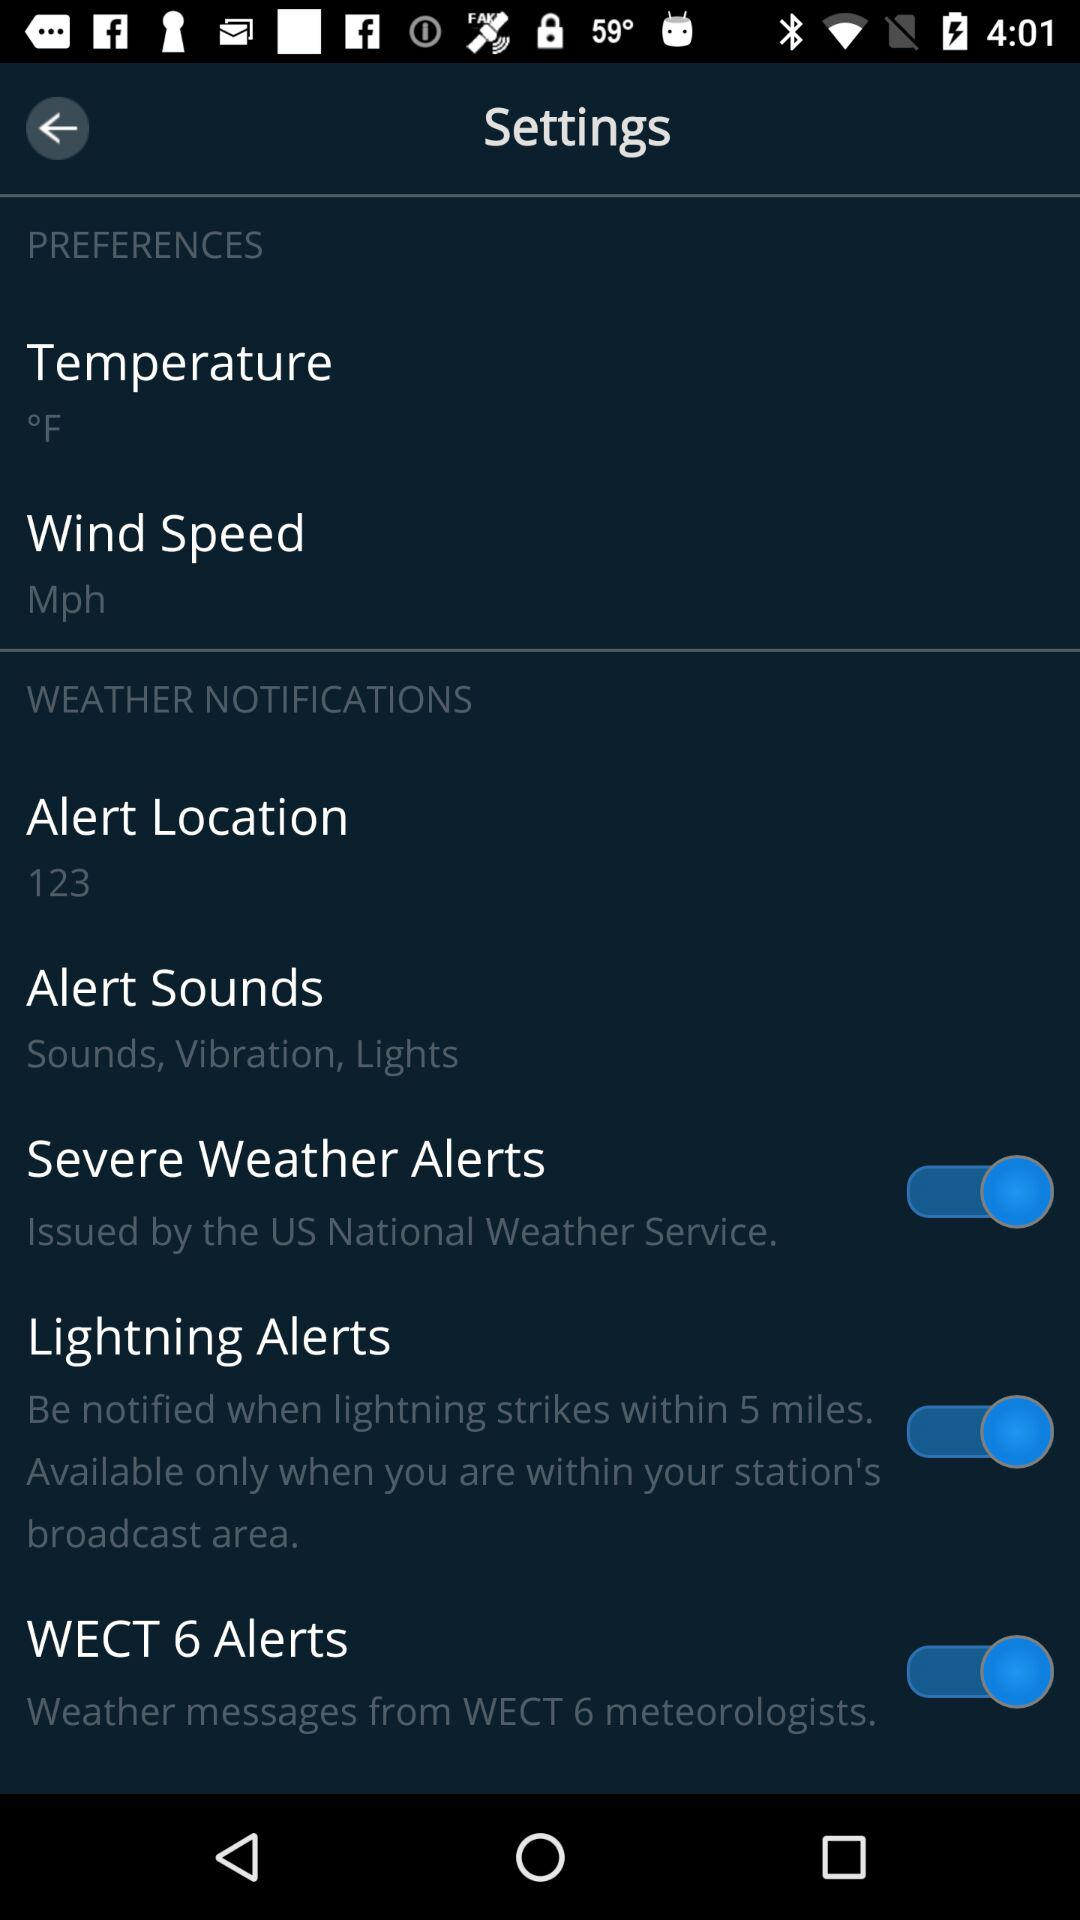How strong is the wind in miles per hour?
When the provided information is insufficient, respond with <no answer>. <no answer> 